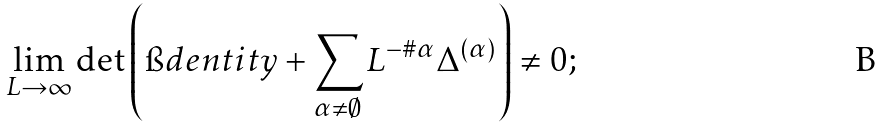<formula> <loc_0><loc_0><loc_500><loc_500>\lim _ { L \to \infty } \det \left ( \i d e n t i t y + \sum _ { \alpha \neq \emptyset } L ^ { - \# \alpha } \Delta ^ { ( \alpha ) } \right ) \neq 0 ;</formula> 